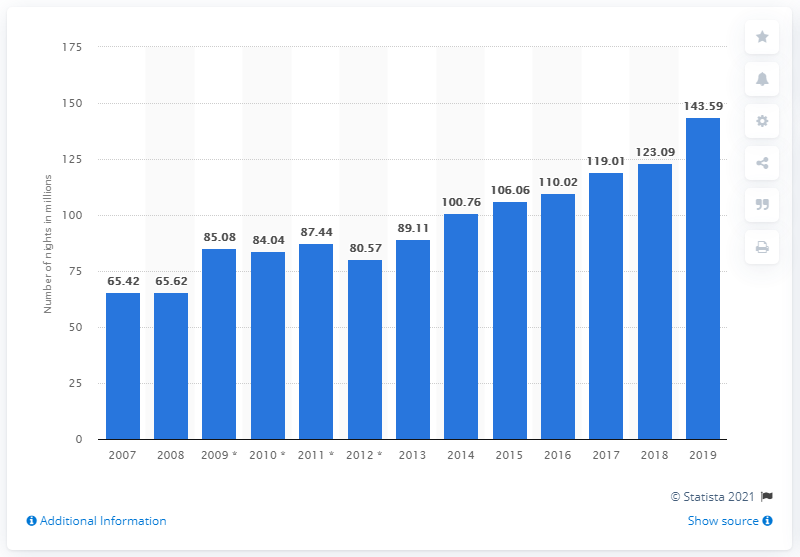Give some essential details in this illustration. In 2019, the number of overnight stays in Greece reached 143.59 nights. 